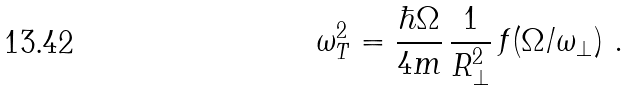<formula> <loc_0><loc_0><loc_500><loc_500>\omega ^ { 2 } _ { T } = \frac { \hbar { \Omega } } { 4 m } \, \frac { 1 } { R _ { \perp } ^ { 2 } } \, f ( \Omega / \omega _ { \perp } ) \ .</formula> 